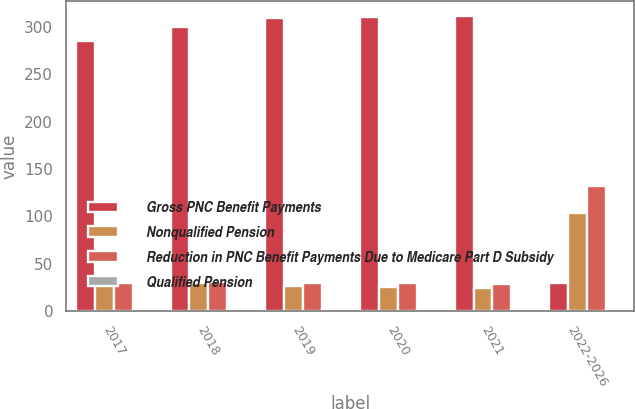Convert chart to OTSL. <chart><loc_0><loc_0><loc_500><loc_500><stacked_bar_chart><ecel><fcel>2017<fcel>2018<fcel>2019<fcel>2020<fcel>2021<fcel>2022-2026<nl><fcel>Gross PNC Benefit Payments<fcel>285<fcel>300<fcel>310<fcel>311<fcel>312<fcel>29<nl><fcel>Nonqualified Pension<fcel>28<fcel>29<fcel>26<fcel>25<fcel>24<fcel>104<nl><fcel>Reduction in PNC Benefit Payments Due to Medicare Part D Subsidy<fcel>29<fcel>30<fcel>29<fcel>29<fcel>28<fcel>132<nl><fcel>Qualified Pension<fcel>1<fcel>1<fcel>1<fcel>1<fcel>1<fcel>2<nl></chart> 